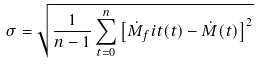<formula> <loc_0><loc_0><loc_500><loc_500>\sigma = \sqrt { \frac { 1 } { n - 1 } \sum _ { t = 0 } ^ { n } \left [ \dot { M } _ { f } i t ( t ) - \dot { M } ( t ) \right ] ^ { 2 } }</formula> 